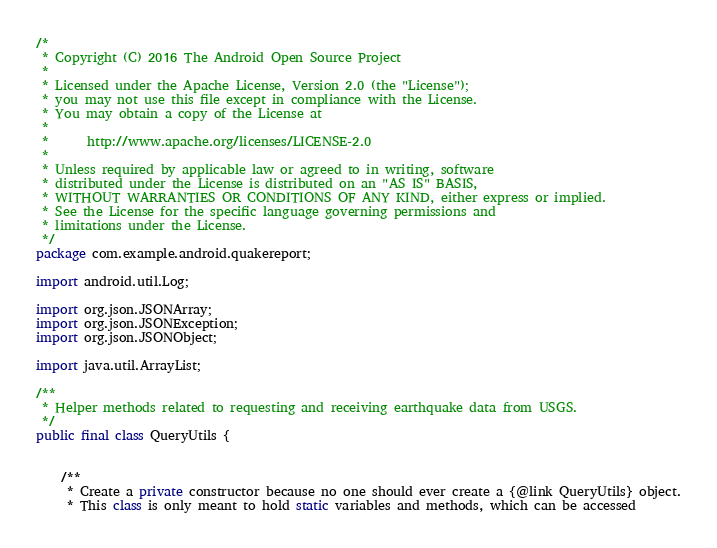<code> <loc_0><loc_0><loc_500><loc_500><_Java_>/*
 * Copyright (C) 2016 The Android Open Source Project
 *
 * Licensed under the Apache License, Version 2.0 (the "License");
 * you may not use this file except in compliance with the License.
 * You may obtain a copy of the License at
 *
 *      http://www.apache.org/licenses/LICENSE-2.0
 *
 * Unless required by applicable law or agreed to in writing, software
 * distributed under the License is distributed on an "AS IS" BASIS,
 * WITHOUT WARRANTIES OR CONDITIONS OF ANY KIND, either express or implied.
 * See the License for the specific language governing permissions and
 * limitations under the License.
 */
package com.example.android.quakereport;

import android.util.Log;

import org.json.JSONArray;
import org.json.JSONException;
import org.json.JSONObject;

import java.util.ArrayList;

/**
 * Helper methods related to requesting and receiving earthquake data from USGS.
 */
public final class QueryUtils {


    /**
     * Create a private constructor because no one should ever create a {@link QueryUtils} object.
     * This class is only meant to hold static variables and methods, which can be accessed</code> 